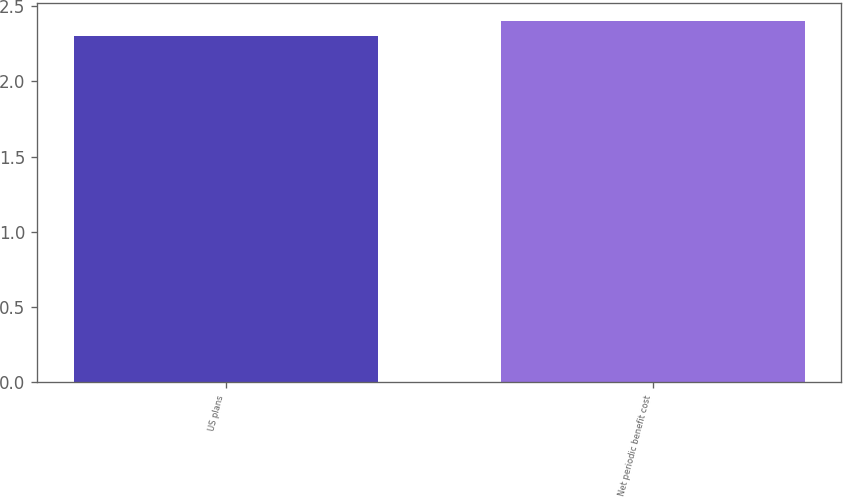Convert chart. <chart><loc_0><loc_0><loc_500><loc_500><bar_chart><fcel>US plans<fcel>Net periodic benefit cost<nl><fcel>2.3<fcel>2.4<nl></chart> 